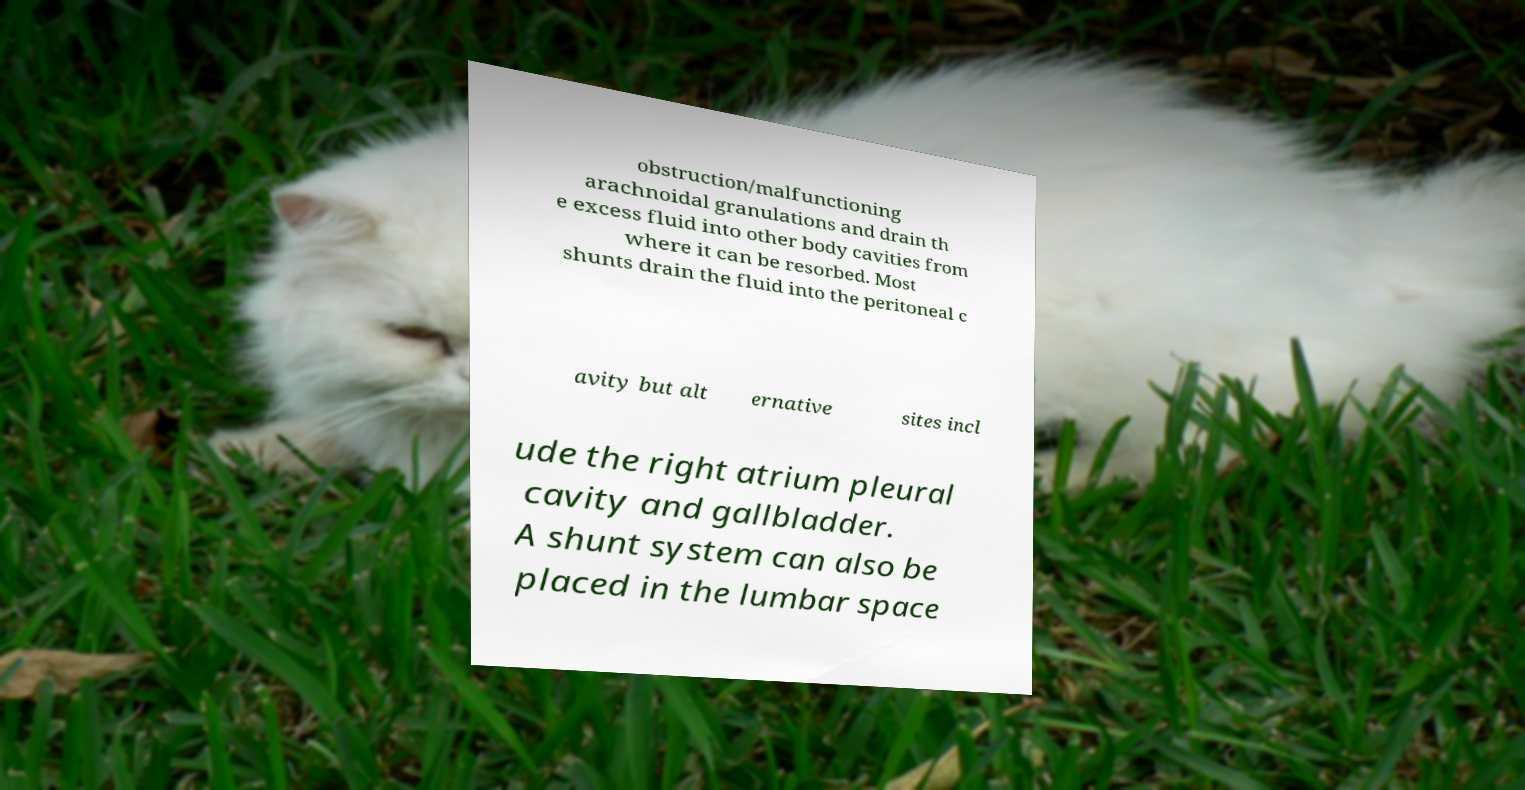I need the written content from this picture converted into text. Can you do that? obstruction/malfunctioning arachnoidal granulations and drain th e excess fluid into other body cavities from where it can be resorbed. Most shunts drain the fluid into the peritoneal c avity but alt ernative sites incl ude the right atrium pleural cavity and gallbladder. A shunt system can also be placed in the lumbar space 